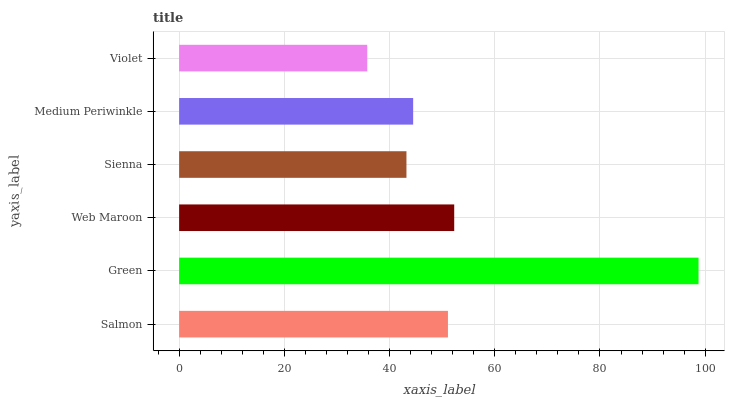Is Violet the minimum?
Answer yes or no. Yes. Is Green the maximum?
Answer yes or no. Yes. Is Web Maroon the minimum?
Answer yes or no. No. Is Web Maroon the maximum?
Answer yes or no. No. Is Green greater than Web Maroon?
Answer yes or no. Yes. Is Web Maroon less than Green?
Answer yes or no. Yes. Is Web Maroon greater than Green?
Answer yes or no. No. Is Green less than Web Maroon?
Answer yes or no. No. Is Salmon the high median?
Answer yes or no. Yes. Is Medium Periwinkle the low median?
Answer yes or no. Yes. Is Violet the high median?
Answer yes or no. No. Is Sienna the low median?
Answer yes or no. No. 